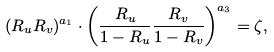<formula> <loc_0><loc_0><loc_500><loc_500>( R _ { u } R _ { v } ) ^ { a _ { 1 } } \cdot \left ( \frac { R _ { u } } { 1 - R _ { u } } \frac { R _ { v } } { 1 - R _ { v } } \right ) ^ { a _ { 3 } } = \zeta ,</formula> 